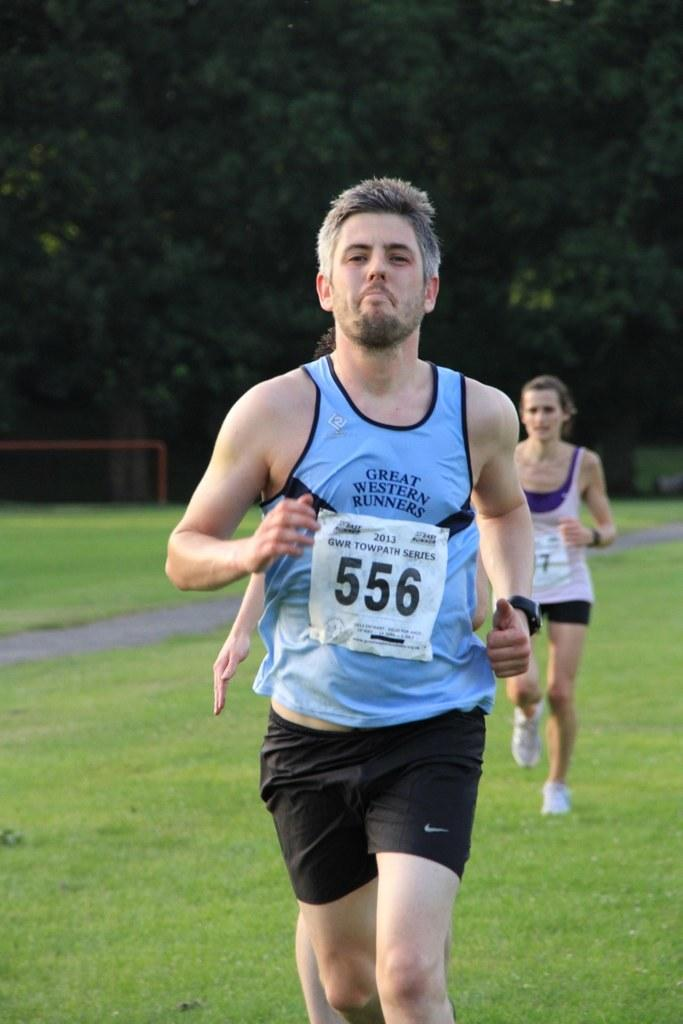<image>
Relay a brief, clear account of the picture shown. Man running while wearing a tag that has the number 556. 